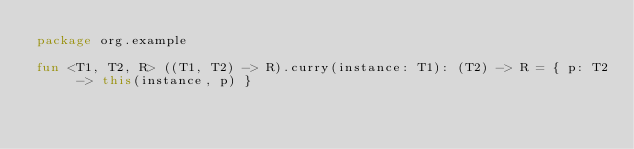Convert code to text. <code><loc_0><loc_0><loc_500><loc_500><_Kotlin_>package org.example

fun <T1, T2, R> ((T1, T2) -> R).curry(instance: T1): (T2) -> R = { p: T2 -> this(instance, p) }</code> 